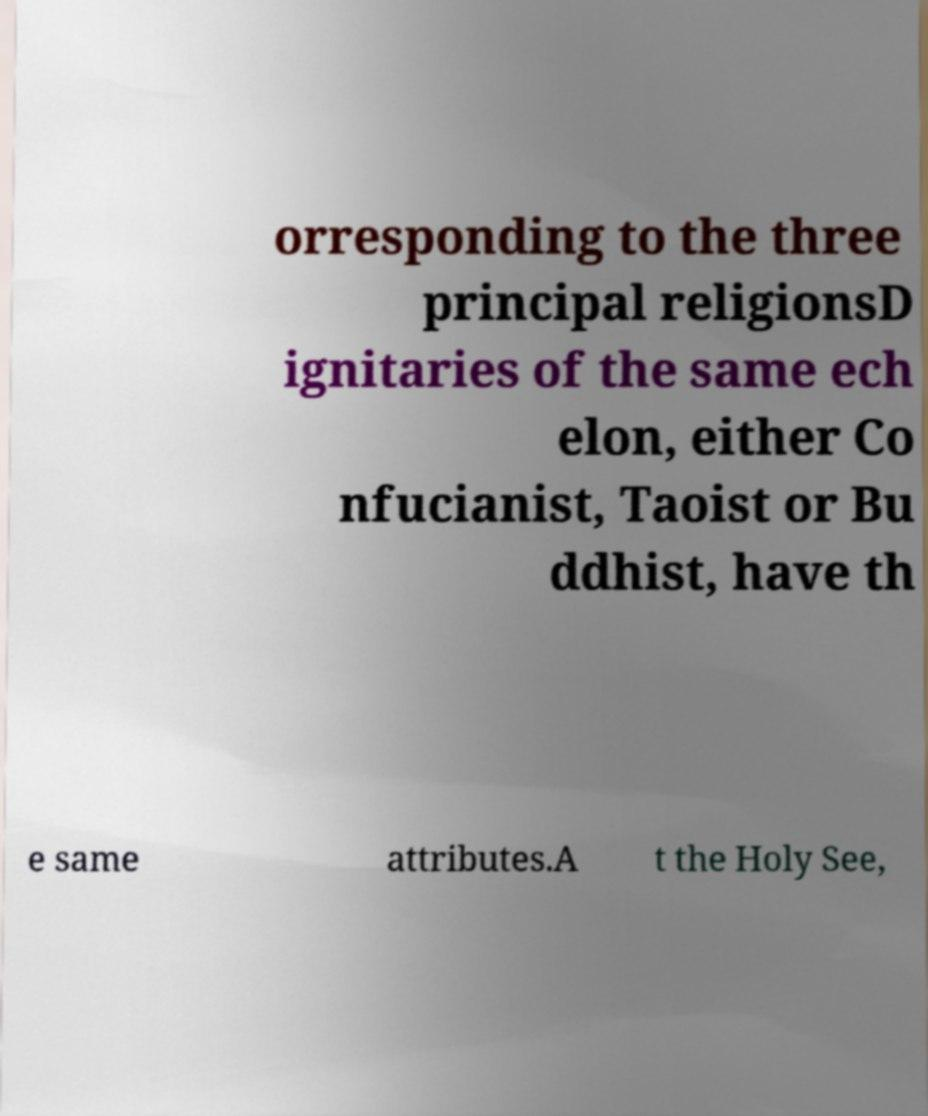Could you extract and type out the text from this image? orresponding to the three principal religionsD ignitaries of the same ech elon, either Co nfucianist, Taoist or Bu ddhist, have th e same attributes.A t the Holy See, 